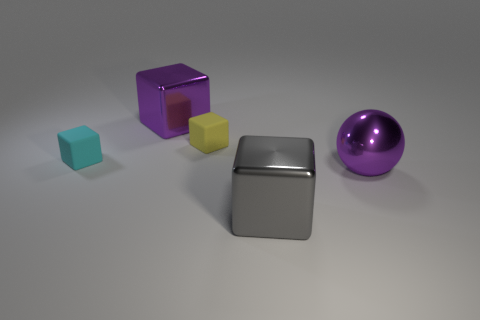Is there another metal object that has the same shape as the yellow thing?
Your answer should be compact. Yes. There is a metal object behind the big purple shiny ball; does it have the same shape as the small matte thing to the right of the cyan object?
Offer a very short reply. Yes. Is there a blue cube that has the same size as the purple cube?
Your answer should be compact. No. Are there an equal number of large purple metallic balls that are behind the large metal ball and small cyan matte things that are behind the small yellow block?
Your answer should be compact. Yes. Do the block that is in front of the big purple sphere and the tiny yellow cube on the right side of the tiny cyan matte cube have the same material?
Your response must be concise. No. What is the material of the gray thing?
Keep it short and to the point. Metal. What number of other things are the same color as the large metal sphere?
Make the answer very short. 1. What number of big purple metal blocks are there?
Keep it short and to the point. 1. There is a small cube to the left of the large metallic block behind the purple metallic ball; what is it made of?
Make the answer very short. Rubber. There is a purple cube that is the same size as the purple ball; what is its material?
Give a very brief answer. Metal. 